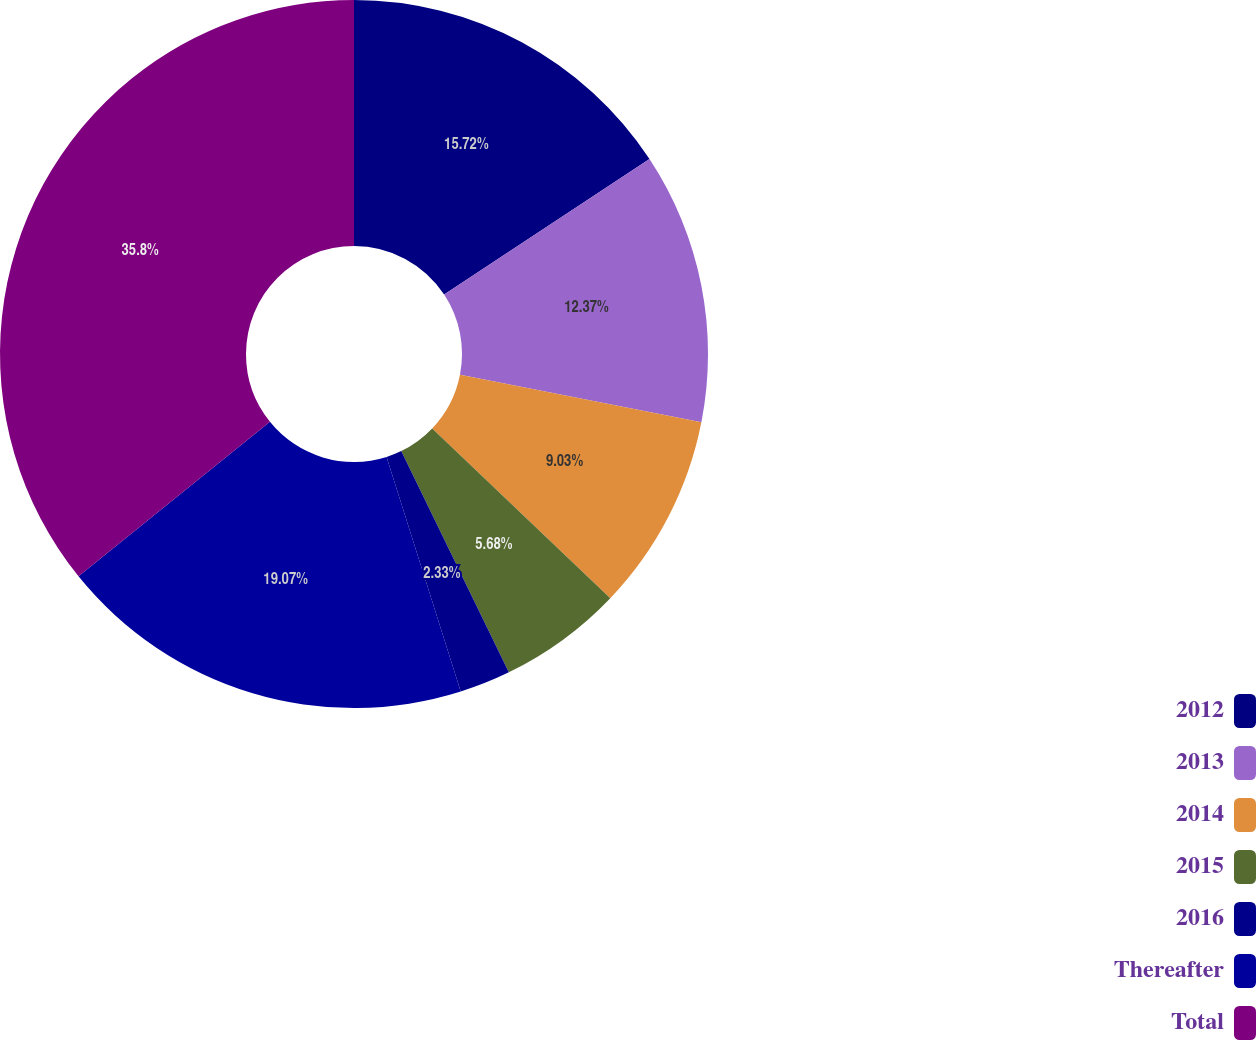<chart> <loc_0><loc_0><loc_500><loc_500><pie_chart><fcel>2012<fcel>2013<fcel>2014<fcel>2015<fcel>2016<fcel>Thereafter<fcel>Total<nl><fcel>15.72%<fcel>12.37%<fcel>9.03%<fcel>5.68%<fcel>2.33%<fcel>19.07%<fcel>35.81%<nl></chart> 